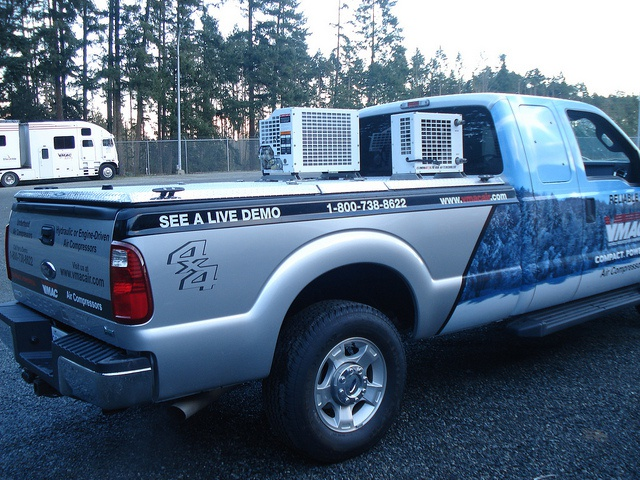Describe the objects in this image and their specific colors. I can see a truck in darkgray, black, navy, gray, and blue tones in this image. 